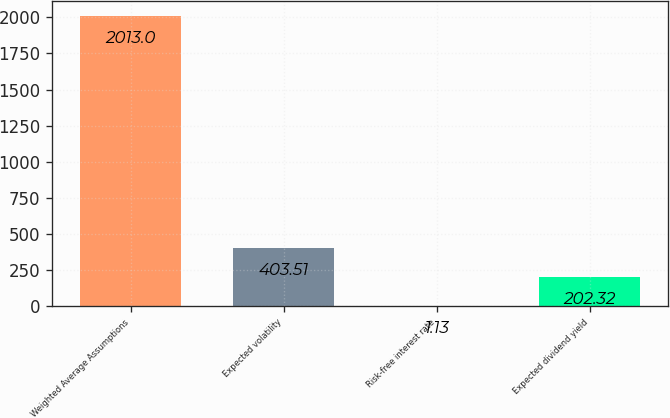Convert chart. <chart><loc_0><loc_0><loc_500><loc_500><bar_chart><fcel>Weighted Average Assumptions<fcel>Expected volatility<fcel>Risk-free interest rate<fcel>Expected dividend yield<nl><fcel>2013<fcel>403.51<fcel>1.13<fcel>202.32<nl></chart> 